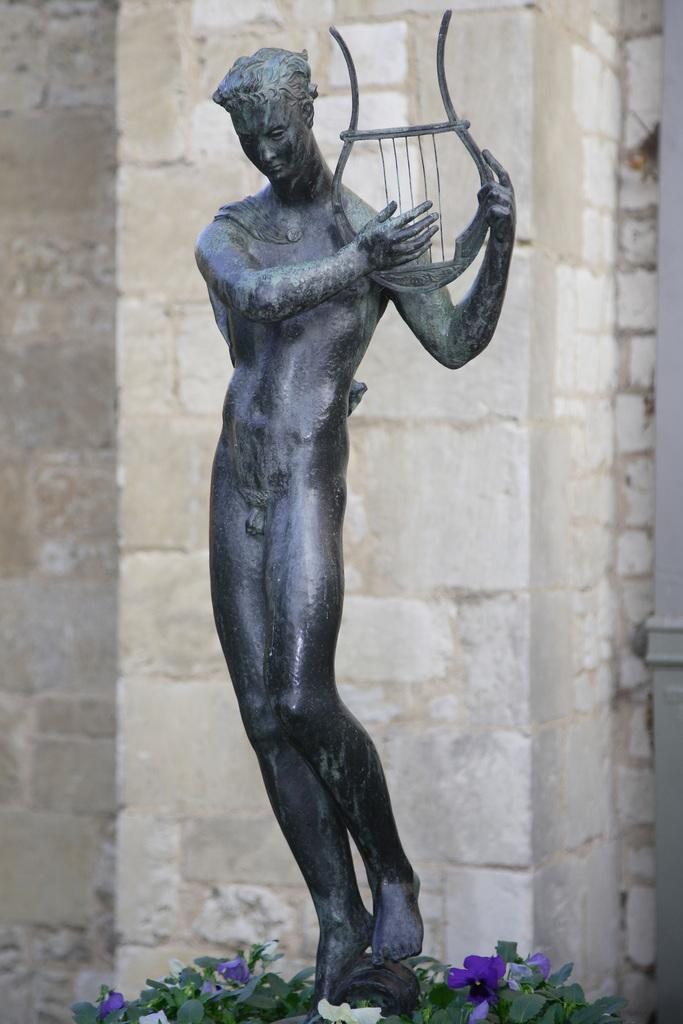What is: What is the main subject in the middle of the image? There is a statue in the middle of the image. What can be seen at the bottom of the image? There are plants and flowers at the bottom of the image. What type of trousers is the writer wearing in the image? There is no writer or trousers present in the image. What is the condition of the sidewalk in the image? There is no sidewalk present in the image. 